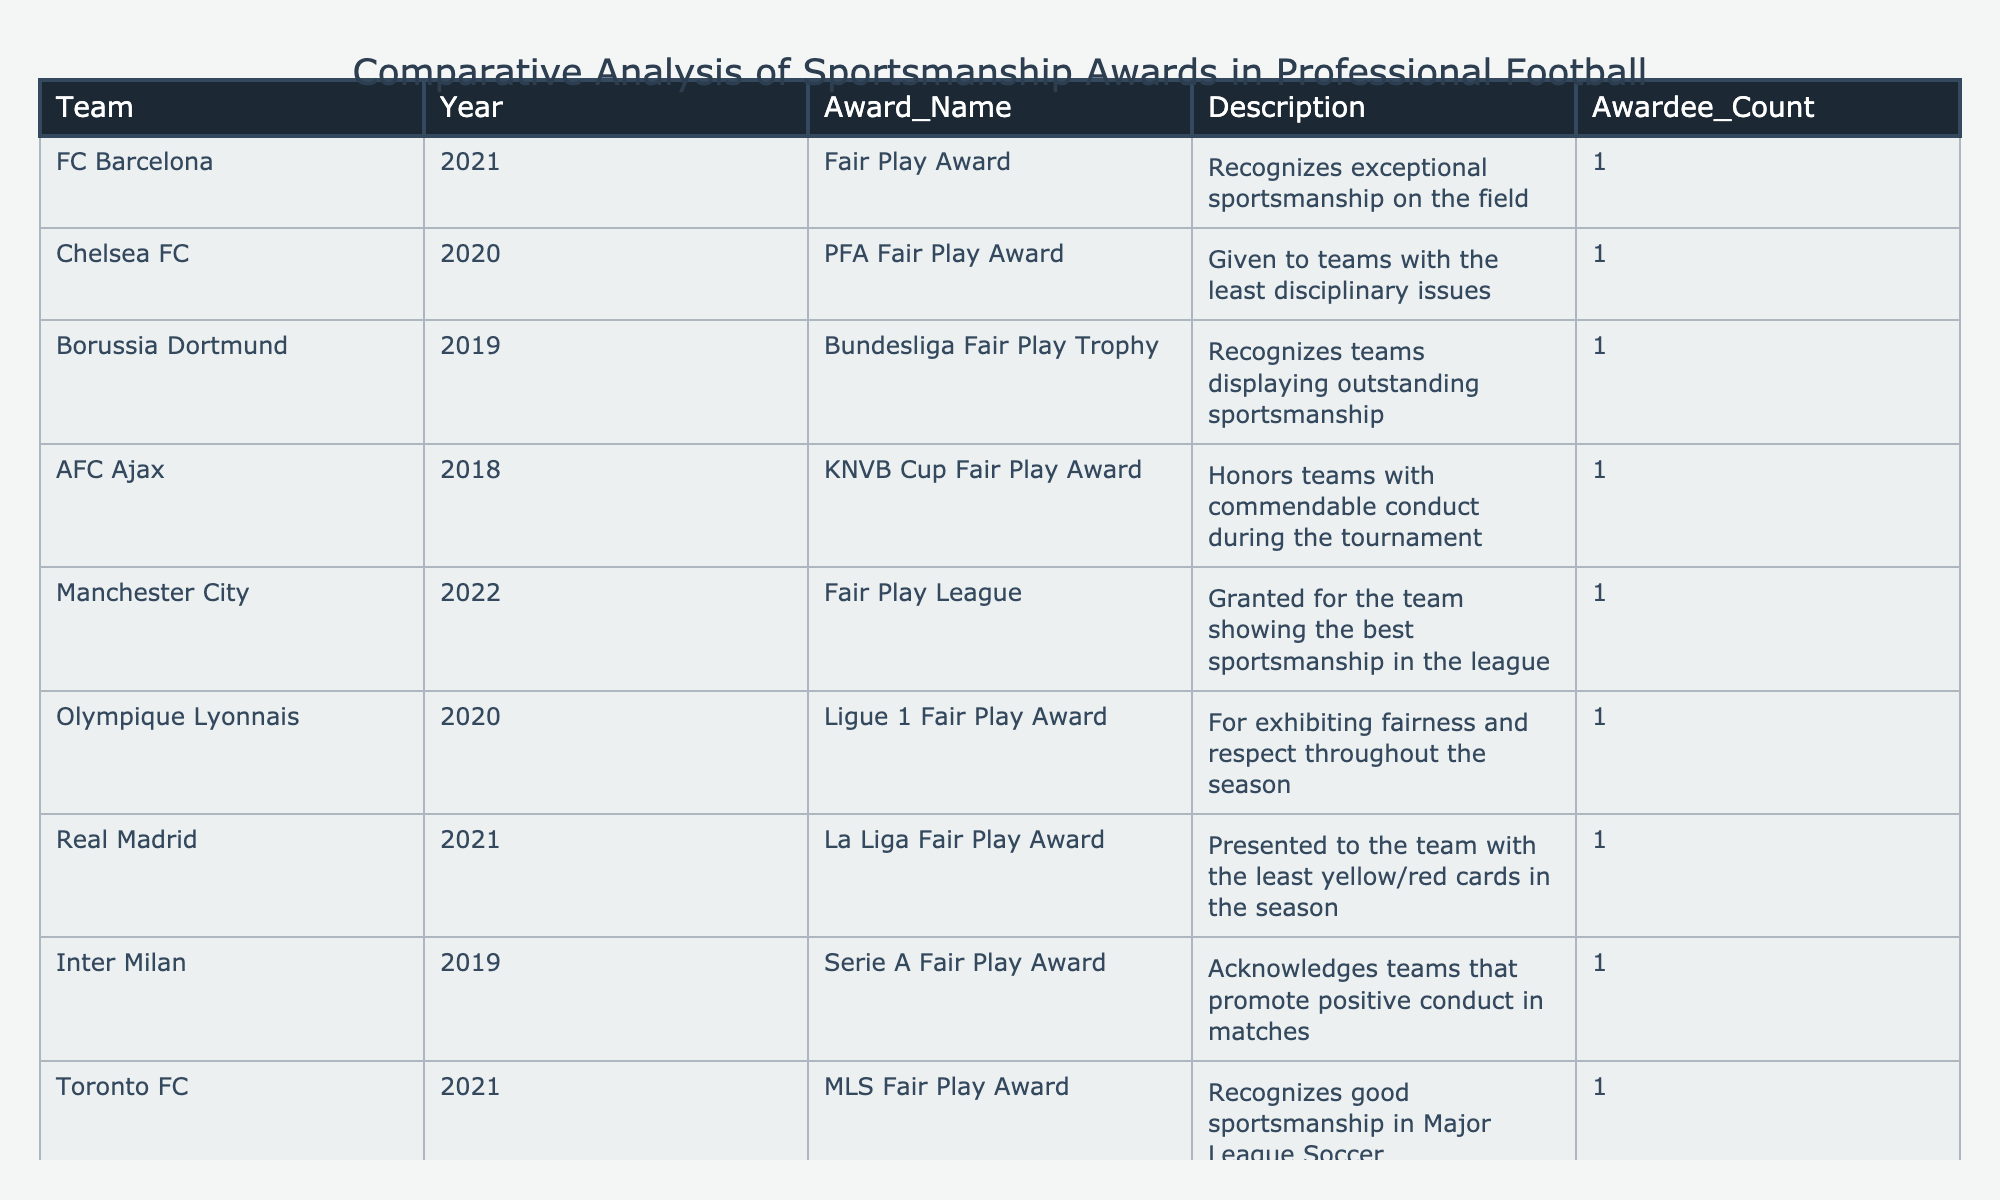What team received the Ligue 1 Fair Play Award in 2020? The table lists Olympique Lyonnais as the recipient of the Ligue 1 Fair Play Award in 2020.
Answer: Olympique Lyonnais How many sportsmanship awards did FC Barcelona receive? According to the table, FC Barcelona received 1 sportsmanship award in 2021.
Answer: 1 Which team received the most recent sportsmanship award in 2022? The table shows that Manchester City received the most recent award in 2022.
Answer: Manchester City Is Chelsea FC the only team to win the PFA Fair Play Award? Yes, Chelsea FC is the only team listed that has won the PFA Fair Play Award in 2020.
Answer: Yes How many teams have won a sportsmanship award since 2019? Since 2019, a total of 5 teams have received sportsmanship awards: Borussia Dortmund (2019), Manchester City (2022), Chelsea FC (2020), Olympique Lyonnais (2020), and Inter Milan (2019).
Answer: 5 How does the number of awards received by Manchester City compare to Real Madrid? Manchester City and Real Madrid each received 1 award; thus, their total awards are equal.
Answer: Equal Which year had the highest number of different teams receiving awards? The year 2020 had 4 different teams receiving awards. They are Chelsea FC, Olympique Lyonnais, Galatasaray, and the Bundesliga Fair Play Trophy.
Answer: 2020 Which country had teams receiving sportsmanship awards in the table? The table indicates teams from Spain, Germany, the Netherlands, England, France, Turkey, and Canada.
Answer: 7 How many teams received awards for the least disciplinary issues? The table shows that 2 teams, Chelsea FC and Real Madrid, received awards for having the least disciplinary issues.
Answer: 2 If we consider only the teams listed in the table, which team has the longest period between award years? The longest period is 3 years between Inter Milan (2019) and Manchester City (2022).
Answer: 3 years 